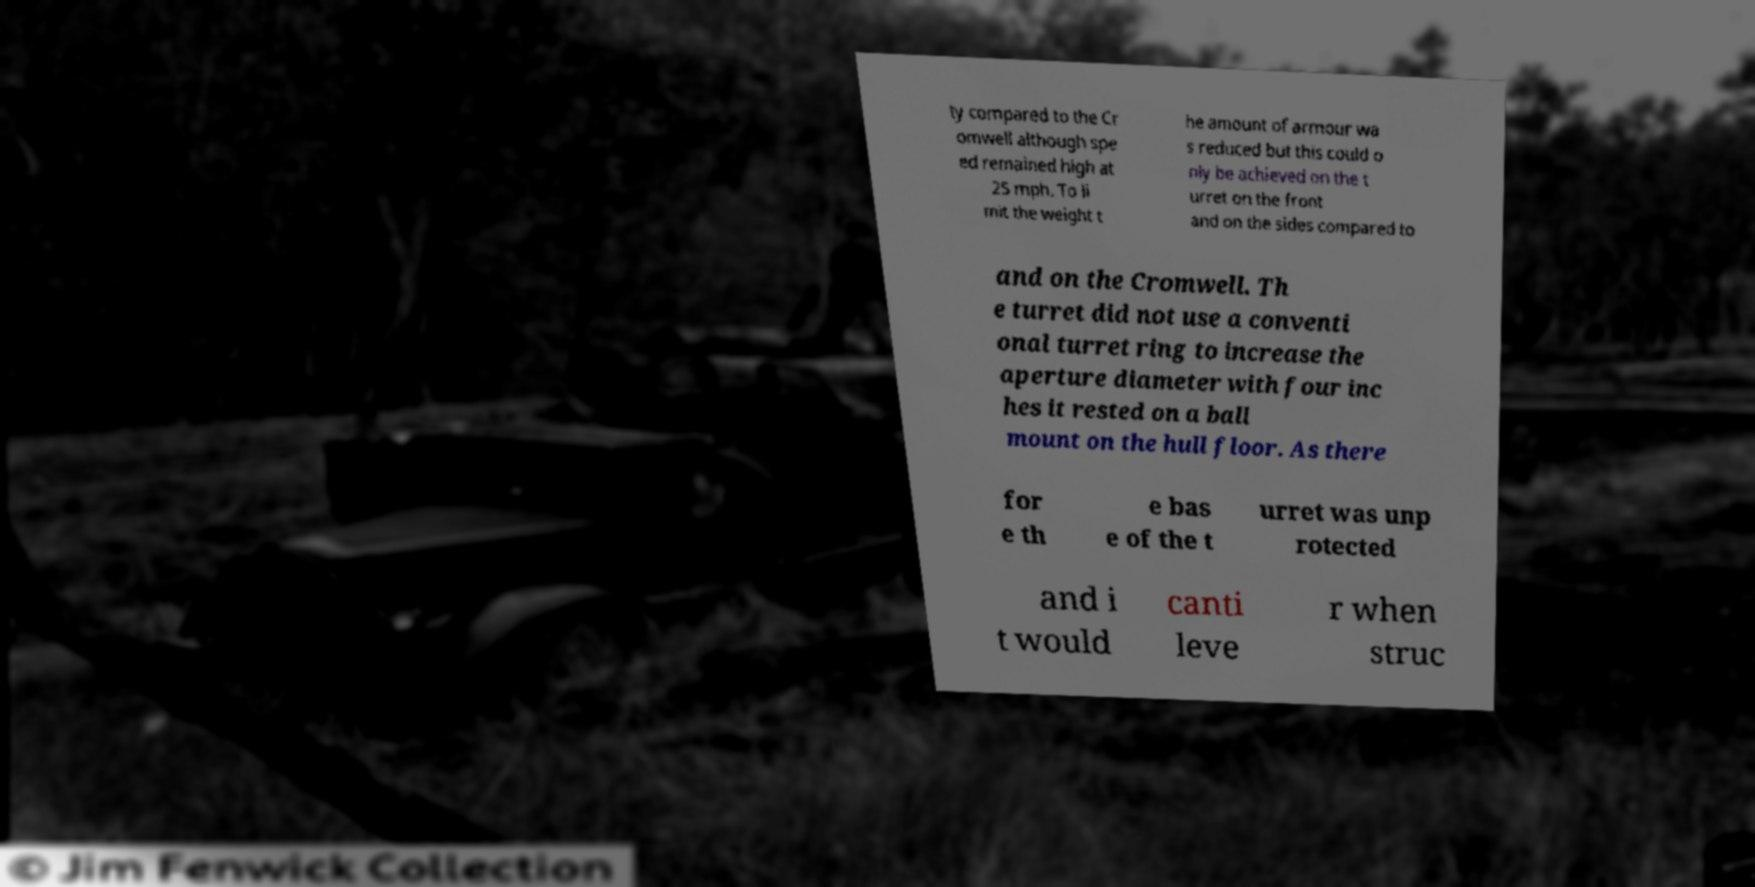Could you extract and type out the text from this image? ty compared to the Cr omwell although spe ed remained high at 25 mph. To li mit the weight t he amount of armour wa s reduced but this could o nly be achieved on the t urret on the front and on the sides compared to and on the Cromwell. Th e turret did not use a conventi onal turret ring to increase the aperture diameter with four inc hes it rested on a ball mount on the hull floor. As there for e th e bas e of the t urret was unp rotected and i t would canti leve r when struc 